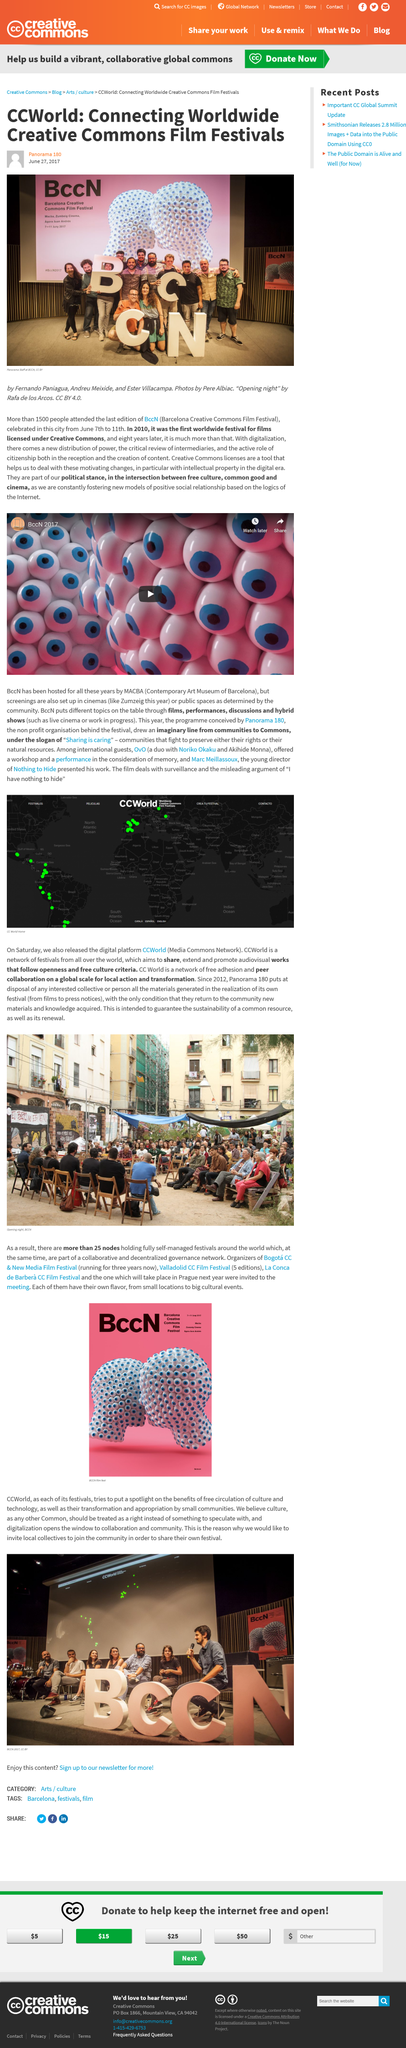Indicate a few pertinent items in this graphic. Digitization enables collaboration and community by providing access to information and resources through digital means. CCWorld is a platform that aims to promote the free circulation of culture and technology. The main image depicts the presence of panorama staff. The Barcelona Creative Commons Film Festival was the first international festival to feature films that were licensed under Creative Commons. In 2017, it is reported that 1500 people attended BccN. 